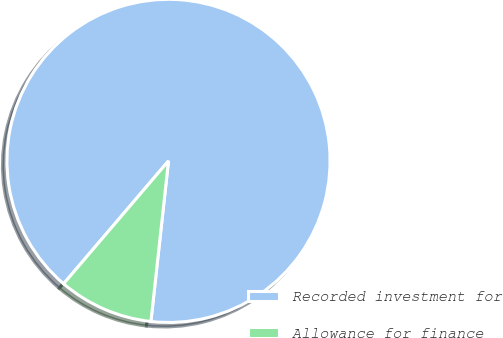<chart> <loc_0><loc_0><loc_500><loc_500><pie_chart><fcel>Recorded investment for<fcel>Allowance for finance<nl><fcel>90.49%<fcel>9.51%<nl></chart> 